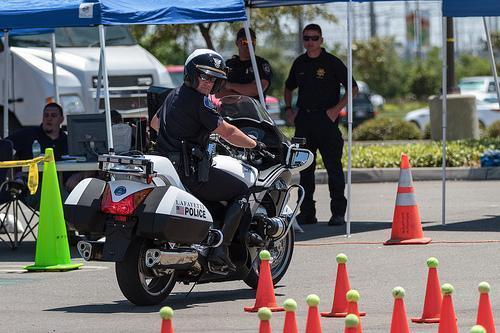How many tennis balls are there?
Give a very brief answer. 13. 